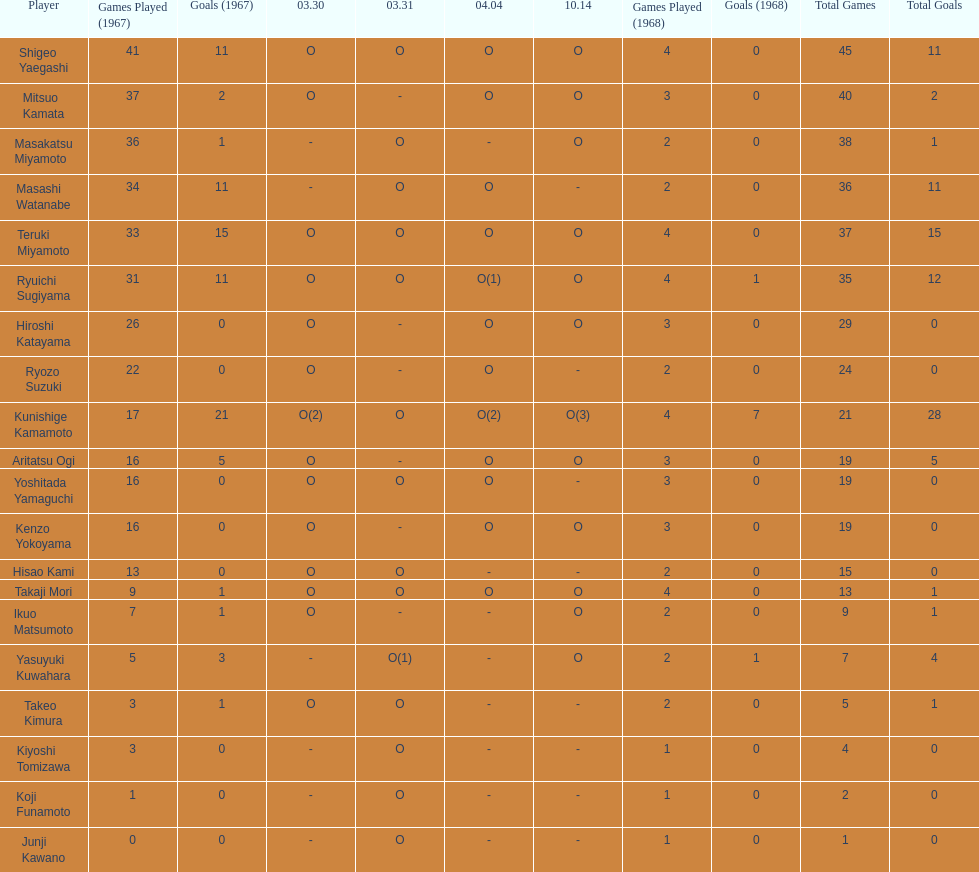How many players made an appearance that year? 20. 